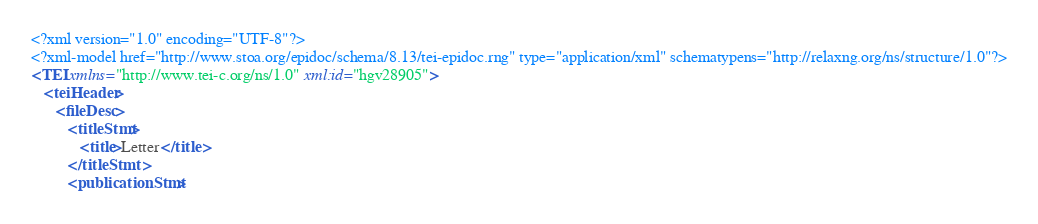<code> <loc_0><loc_0><loc_500><loc_500><_XML_><?xml version="1.0" encoding="UTF-8"?>
<?xml-model href="http://www.stoa.org/epidoc/schema/8.13/tei-epidoc.rng" type="application/xml" schematypens="http://relaxng.org/ns/structure/1.0"?>
<TEI xmlns="http://www.tei-c.org/ns/1.0" xml:id="hgv28905">
   <teiHeader>
      <fileDesc>
         <titleStmt>
            <title>Letter</title>
         </titleStmt>
         <publicationStmt></code> 